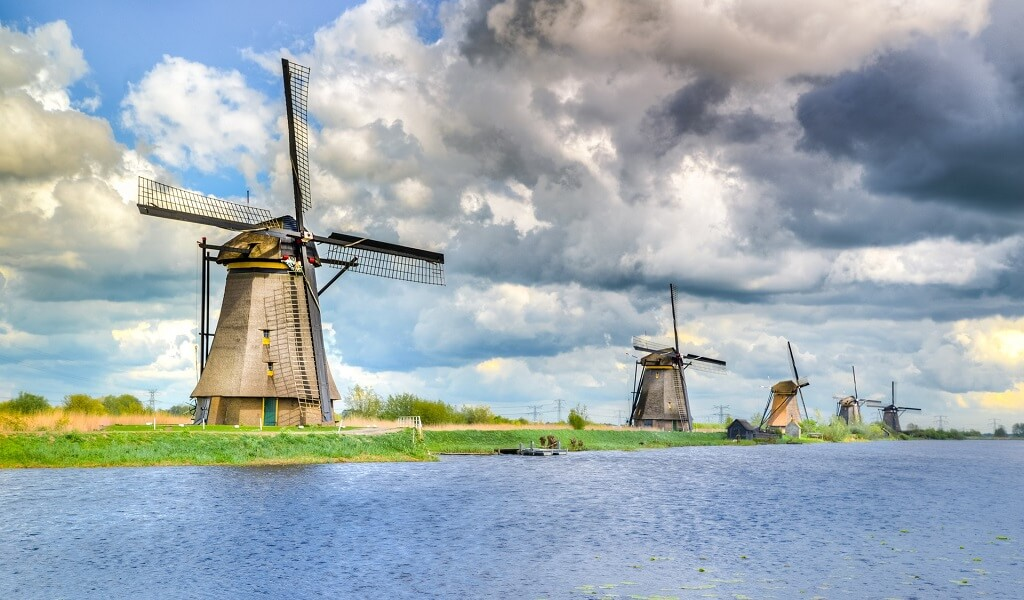Imagine standing right by this canal. What would you hear, see, and feel? Standing by this canal, you'd be enveloped in the soft murmurs of the breeze as it gently rustles through the grass and the blades of the windmills. The tranquil sounds of water gently lapping against the canal banks would be a constant backdrop. Birds might occasionally chirp or flit across the sky, adding to the serene ambiance. Visually, the sprawling green meadows, the sturdy windmills, and the vast, open sky would dominate your view. You'd feel the cool breeze on your skin, carrying with it the fresh, earthy scent of the meadows and the faint moisture from the canal. It's a sensory symphony of peace and simplicity, truly capturing the essence of the Dutch countryside. Could you use the sight of these windmills in a poetic context? Absolutely, here's a poetic take: 'In the dance of time's embrace, they stand — the guardians of the meadows, their sails outstretched like wings poised to kiss the sky. Beneath the canvas of azure and rolling silver, whispers of history wind through their wooden bones. Here, in this realm of earth and water, they tell tales of resilience and harmony, their silhouettes etched against the horizon, timeless in their quiet grandeur.' 